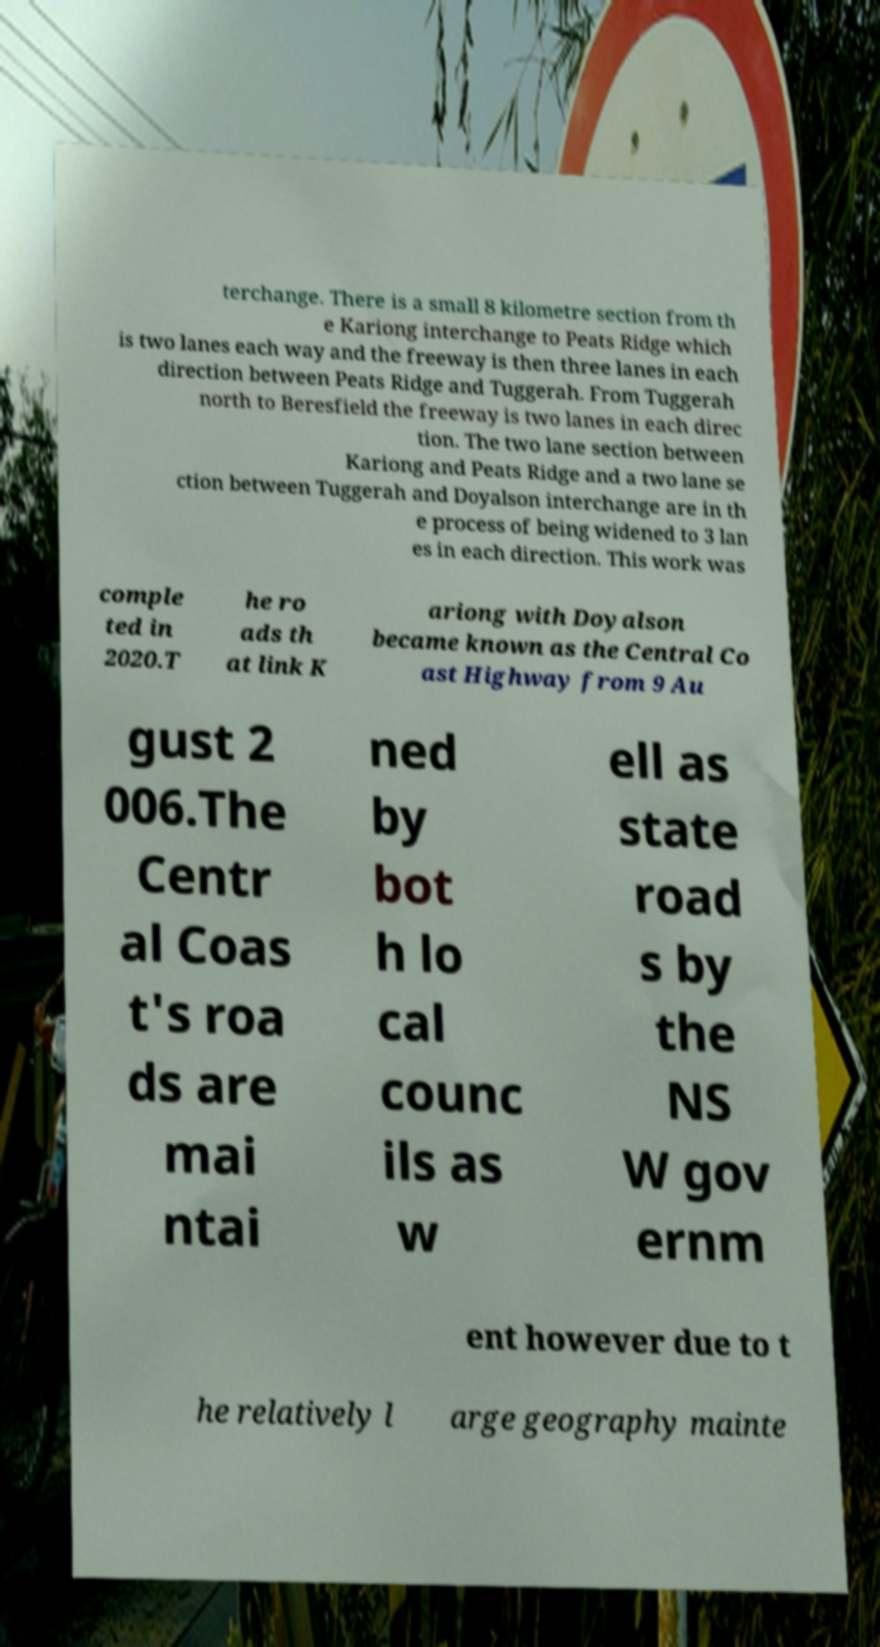For documentation purposes, I need the text within this image transcribed. Could you provide that? terchange. There is a small 8 kilometre section from th e Kariong interchange to Peats Ridge which is two lanes each way and the freeway is then three lanes in each direction between Peats Ridge and Tuggerah. From Tuggerah north to Beresfield the freeway is two lanes in each direc tion. The two lane section between Kariong and Peats Ridge and a two lane se ction between Tuggerah and Doyalson interchange are in th e process of being widened to 3 lan es in each direction. This work was comple ted in 2020.T he ro ads th at link K ariong with Doyalson became known as the Central Co ast Highway from 9 Au gust 2 006.The Centr al Coas t's roa ds are mai ntai ned by bot h lo cal counc ils as w ell as state road s by the NS W gov ernm ent however due to t he relatively l arge geography mainte 